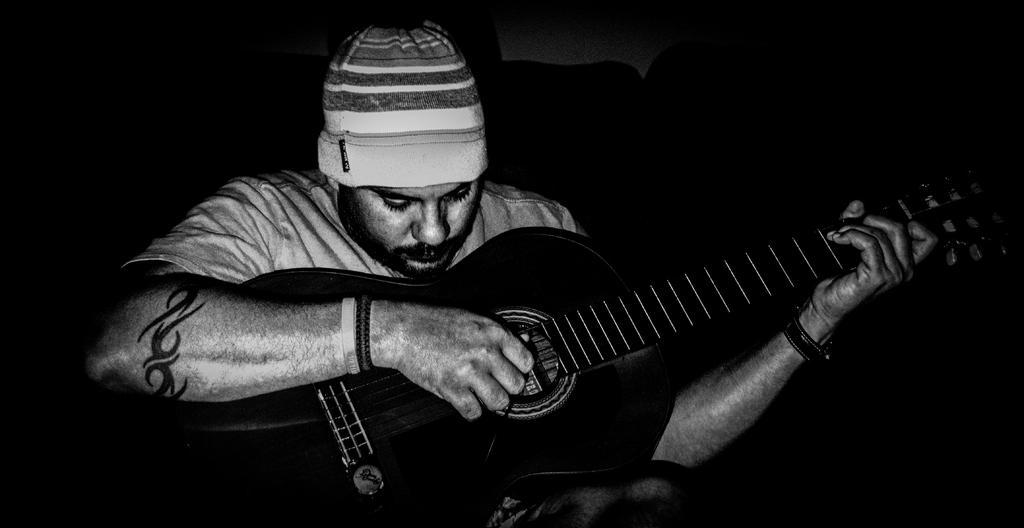How would you summarize this image in a sentence or two? Here we can see a man playing a guitar 